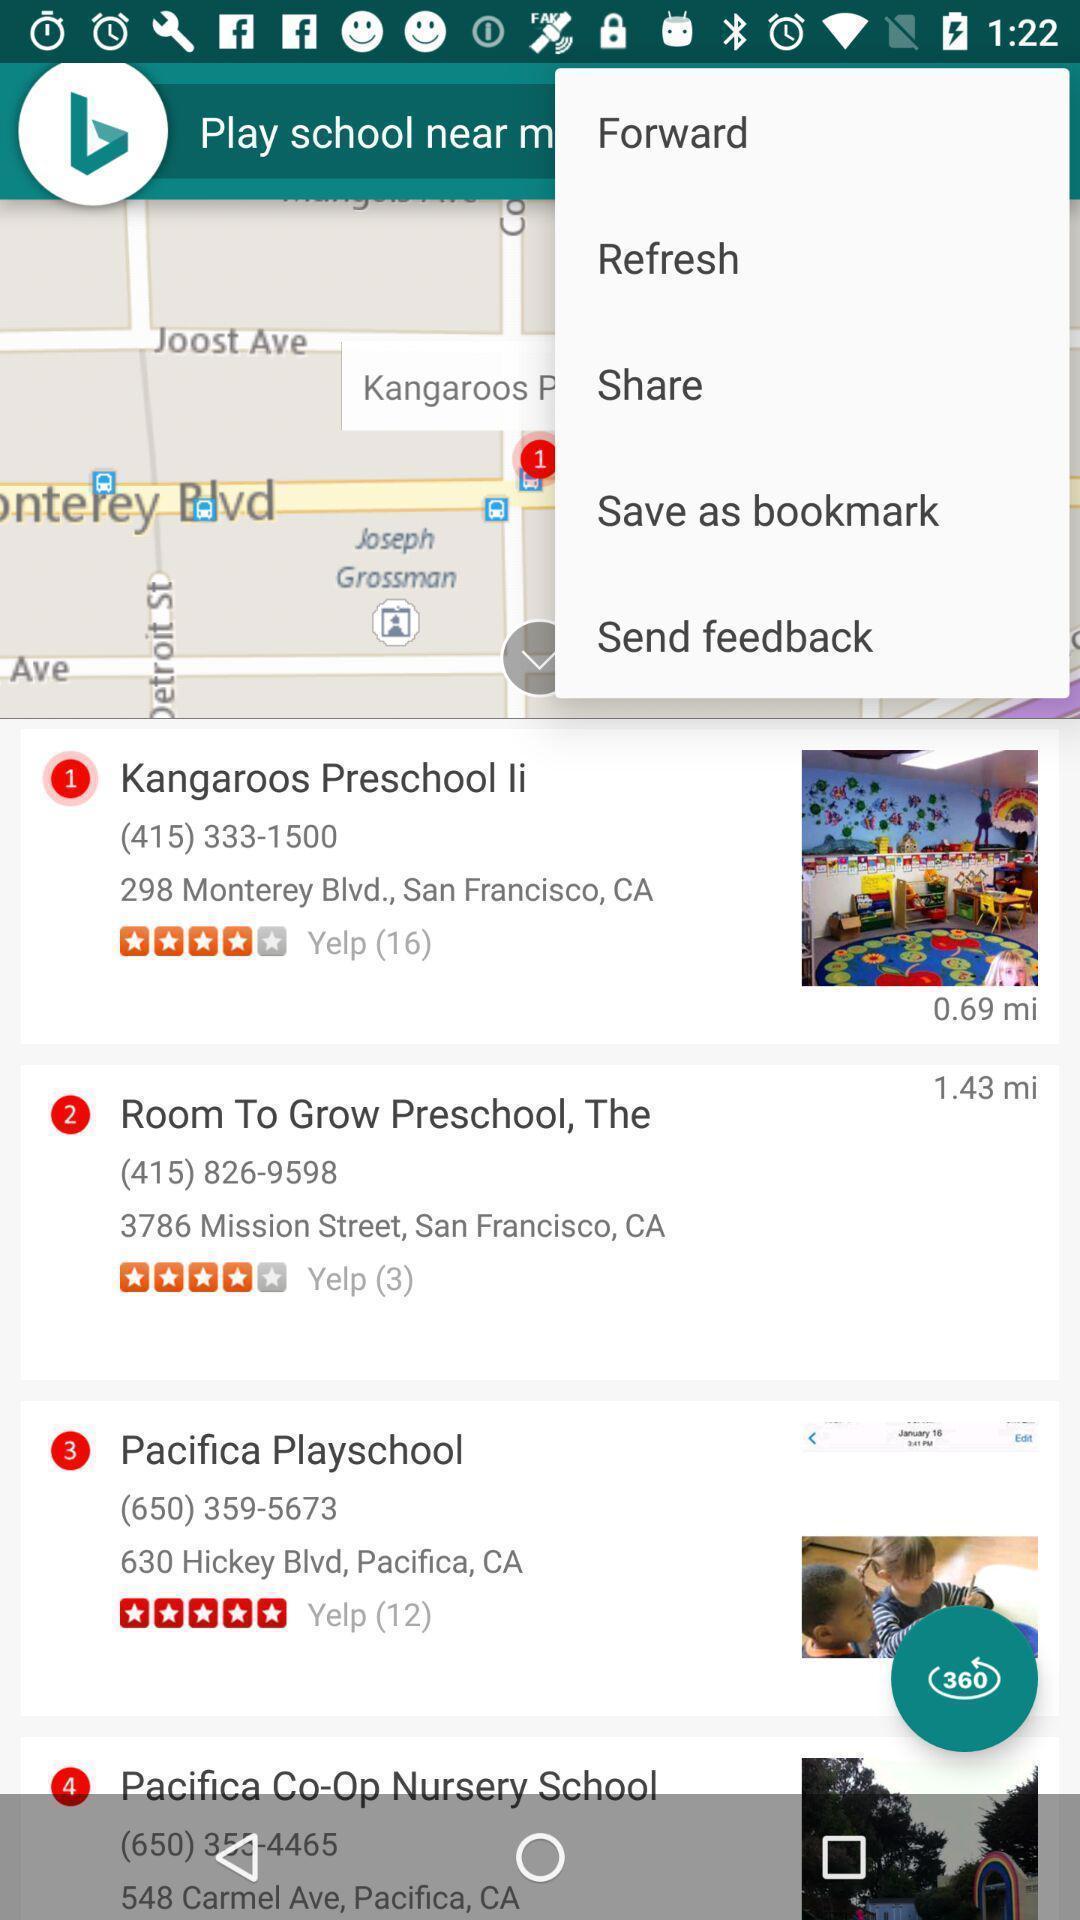Provide a textual representation of this image. Page showing various actions in a map. 